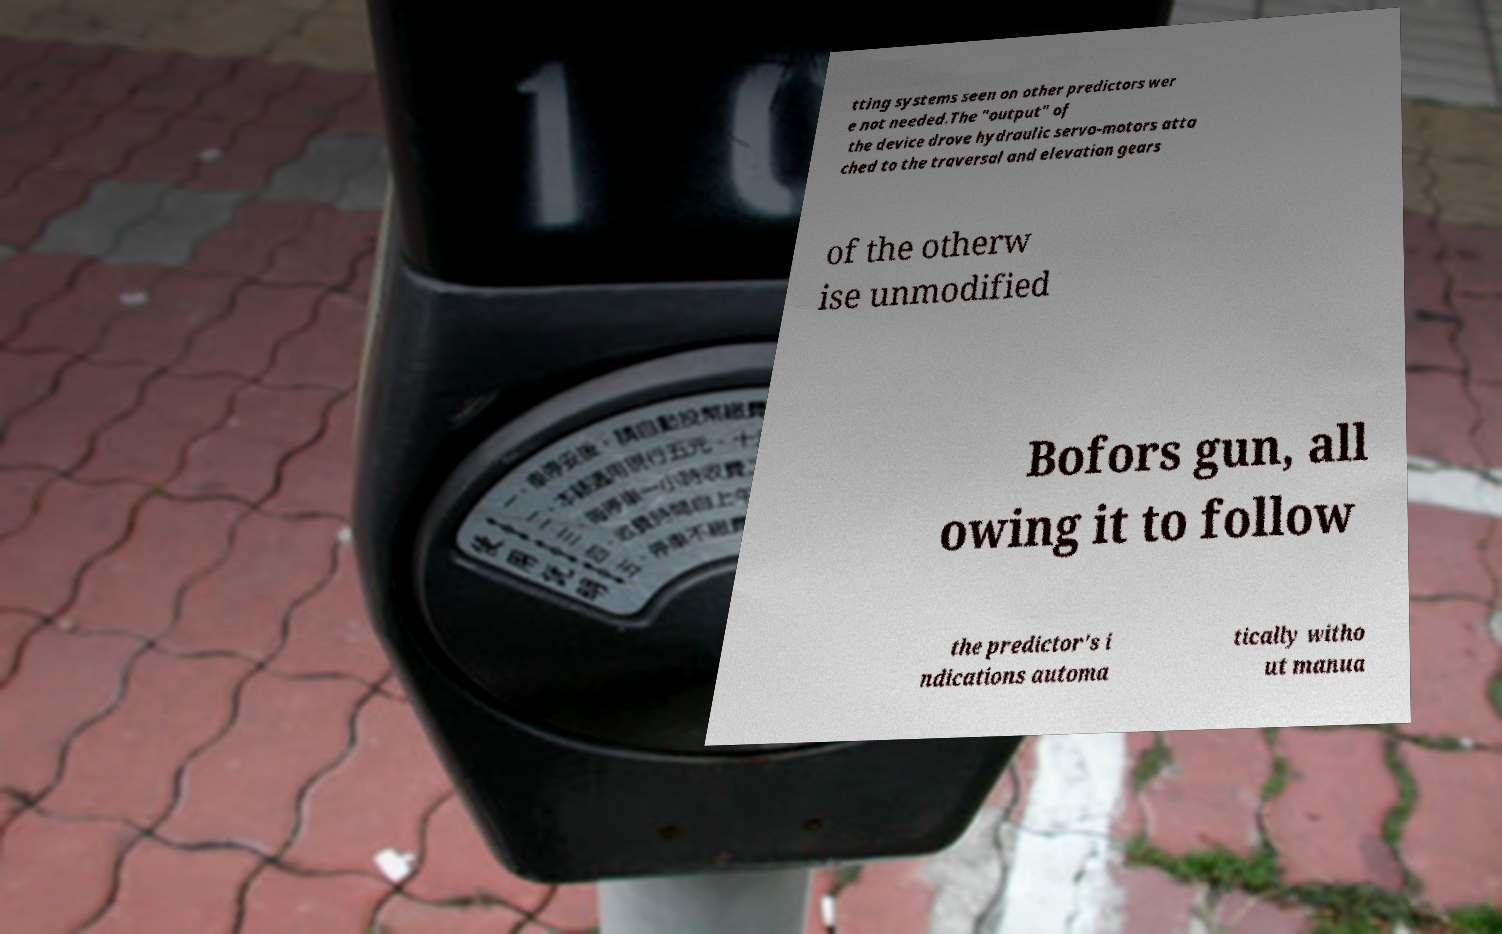There's text embedded in this image that I need extracted. Can you transcribe it verbatim? tting systems seen on other predictors wer e not needed.The "output" of the device drove hydraulic servo-motors atta ched to the traversal and elevation gears of the otherw ise unmodified Bofors gun, all owing it to follow the predictor's i ndications automa tically witho ut manua 